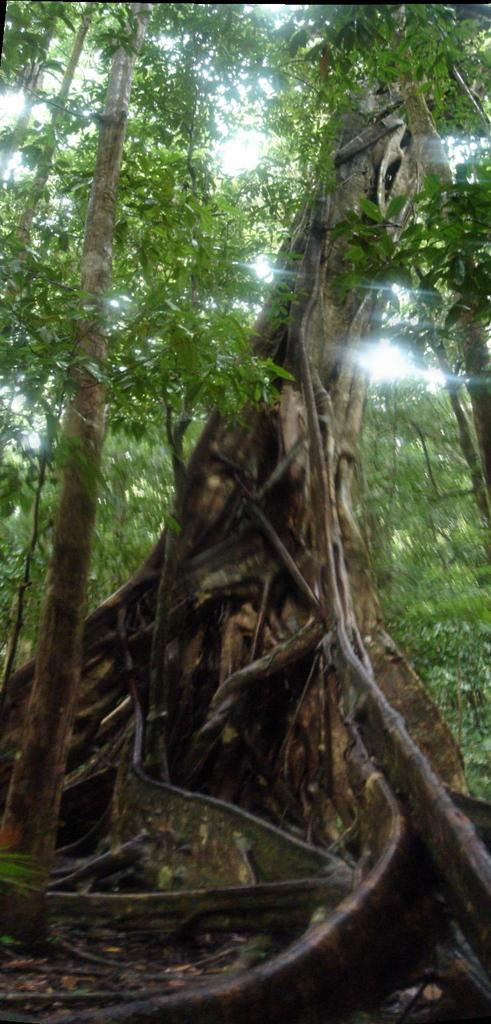What type of vegetation can be seen in the image? There are trees in the image. What is present at the bottom of the image? Dry leaves are present at the bottom of the image. What material are the sticks in the image made of? The sticks in the image are made of wood. What type of yam is growing on the trees in the image? There are no yams present in the image; it features trees with dry leaves and wooden sticks. Can you see any stones in the image? There are no stones visible in the image. 